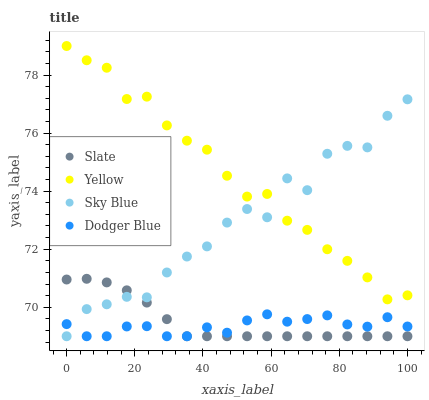Does Dodger Blue have the minimum area under the curve?
Answer yes or no. Yes. Does Yellow have the maximum area under the curve?
Answer yes or no. Yes. Does Slate have the minimum area under the curve?
Answer yes or no. No. Does Slate have the maximum area under the curve?
Answer yes or no. No. Is Slate the smoothest?
Answer yes or no. Yes. Is Sky Blue the roughest?
Answer yes or no. Yes. Is Dodger Blue the smoothest?
Answer yes or no. No. Is Dodger Blue the roughest?
Answer yes or no. No. Does Sky Blue have the lowest value?
Answer yes or no. Yes. Does Yellow have the lowest value?
Answer yes or no. No. Does Yellow have the highest value?
Answer yes or no. Yes. Does Slate have the highest value?
Answer yes or no. No. Is Dodger Blue less than Yellow?
Answer yes or no. Yes. Is Yellow greater than Slate?
Answer yes or no. Yes. Does Slate intersect Sky Blue?
Answer yes or no. Yes. Is Slate less than Sky Blue?
Answer yes or no. No. Is Slate greater than Sky Blue?
Answer yes or no. No. Does Dodger Blue intersect Yellow?
Answer yes or no. No. 